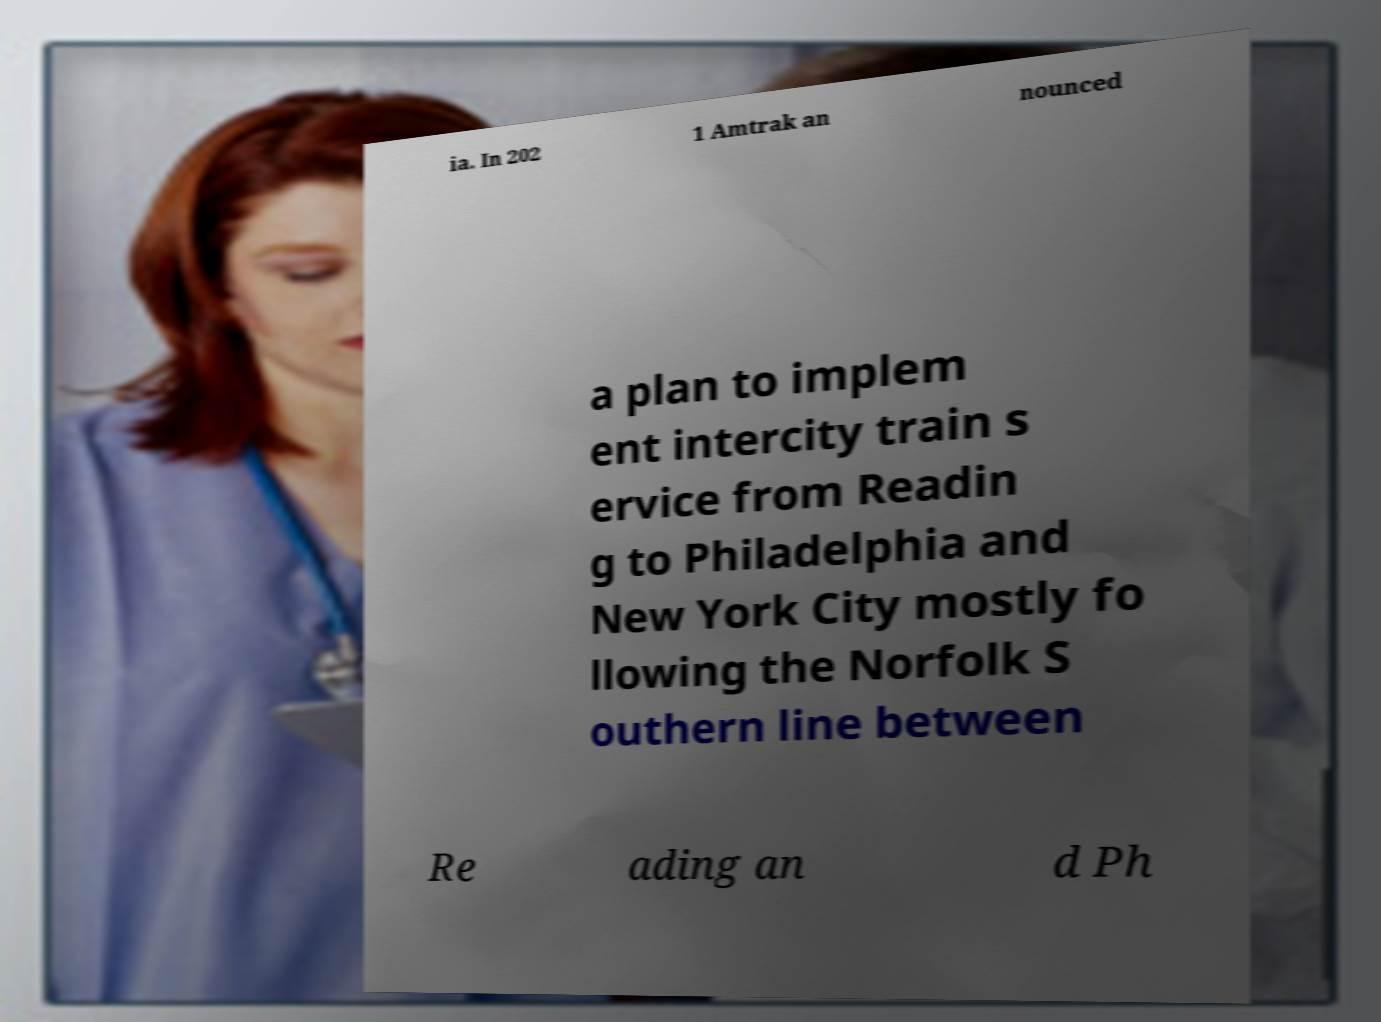Can you read and provide the text displayed in the image?This photo seems to have some interesting text. Can you extract and type it out for me? ia. In 202 1 Amtrak an nounced a plan to implem ent intercity train s ervice from Readin g to Philadelphia and New York City mostly fo llowing the Norfolk S outhern line between Re ading an d Ph 